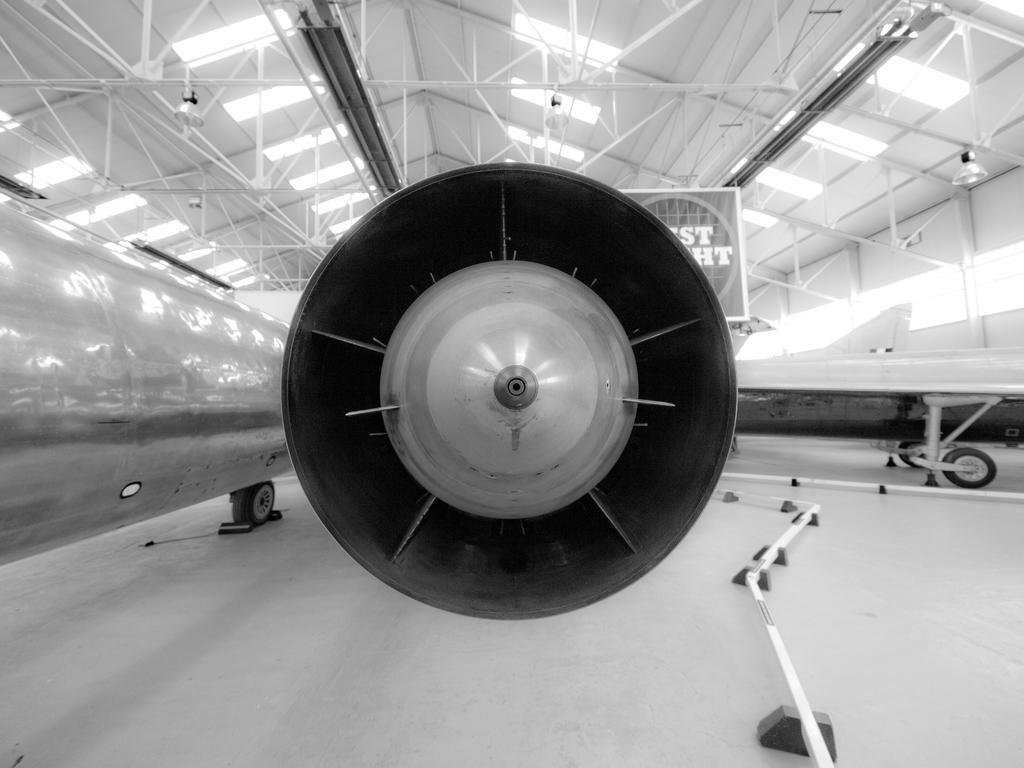Could you give a brief overview of what you see in this image? This is a black and white image. In the center of the image there is a aeroplane. At the top of the image there is ceiling with rods. At the bottom of the image there is floor. 